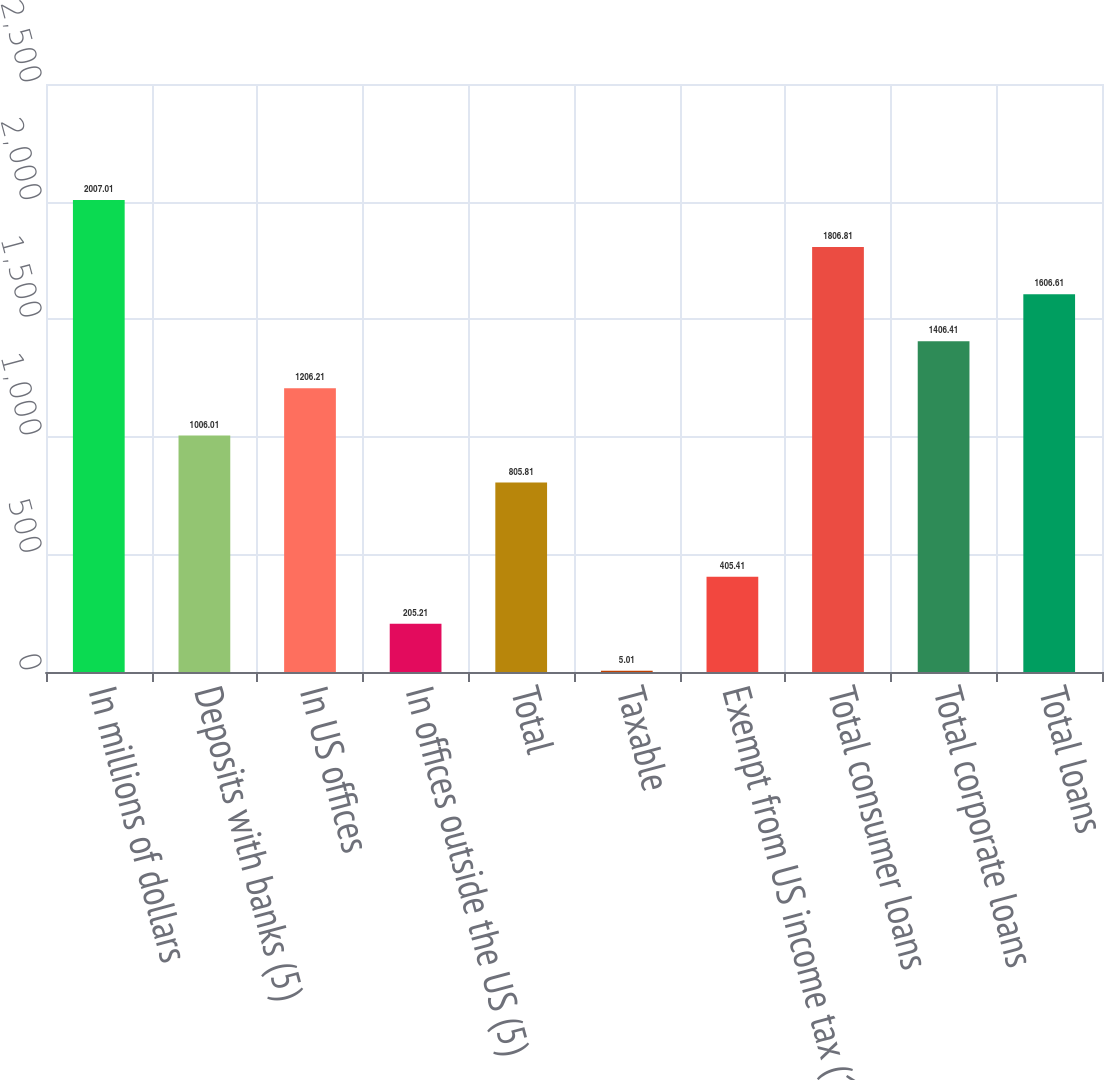Convert chart to OTSL. <chart><loc_0><loc_0><loc_500><loc_500><bar_chart><fcel>In millions of dollars<fcel>Deposits with banks (5)<fcel>In US offices<fcel>In offices outside the US (5)<fcel>Total<fcel>Taxable<fcel>Exempt from US income tax (1)<fcel>Total consumer loans<fcel>Total corporate loans<fcel>Total loans<nl><fcel>2007.01<fcel>1006.01<fcel>1206.21<fcel>205.21<fcel>805.81<fcel>5.01<fcel>405.41<fcel>1806.81<fcel>1406.41<fcel>1606.61<nl></chart> 